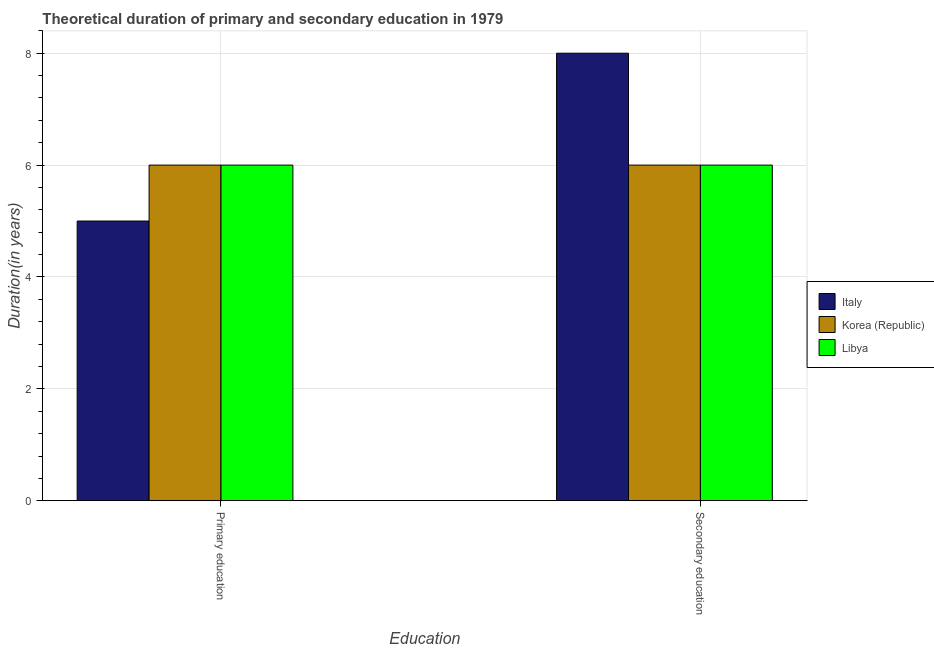How many different coloured bars are there?
Offer a very short reply. 3. How many groups of bars are there?
Provide a succinct answer. 2. Are the number of bars per tick equal to the number of legend labels?
Provide a succinct answer. Yes. How many bars are there on the 1st tick from the right?
Provide a succinct answer. 3. What is the label of the 2nd group of bars from the left?
Provide a succinct answer. Secondary education. What is the duration of secondary education in Korea (Republic)?
Give a very brief answer. 6. Across all countries, what is the minimum duration of primary education?
Offer a very short reply. 5. In which country was the duration of primary education maximum?
Provide a short and direct response. Korea (Republic). In which country was the duration of secondary education minimum?
Offer a very short reply. Korea (Republic). What is the total duration of primary education in the graph?
Provide a short and direct response. 17. What is the difference between the duration of secondary education in Libya and that in Italy?
Offer a terse response. -2. What is the difference between the duration of secondary education in Libya and the duration of primary education in Korea (Republic)?
Keep it short and to the point. 0. What is the average duration of secondary education per country?
Provide a short and direct response. 6.67. What is the ratio of the duration of primary education in Korea (Republic) to that in Libya?
Offer a terse response. 1. Is the duration of primary education in Italy less than that in Korea (Republic)?
Offer a very short reply. Yes. What does the 2nd bar from the left in Secondary education represents?
Give a very brief answer. Korea (Republic). What does the 1st bar from the right in Primary education represents?
Ensure brevity in your answer.  Libya. How many bars are there?
Make the answer very short. 6. Are all the bars in the graph horizontal?
Your answer should be compact. No. How many countries are there in the graph?
Provide a short and direct response. 3. What is the difference between two consecutive major ticks on the Y-axis?
Offer a very short reply. 2. Are the values on the major ticks of Y-axis written in scientific E-notation?
Keep it short and to the point. No. Does the graph contain any zero values?
Ensure brevity in your answer.  No. Does the graph contain grids?
Your answer should be very brief. Yes. How many legend labels are there?
Your answer should be very brief. 3. What is the title of the graph?
Your response must be concise. Theoretical duration of primary and secondary education in 1979. What is the label or title of the X-axis?
Provide a short and direct response. Education. What is the label or title of the Y-axis?
Your response must be concise. Duration(in years). What is the Duration(in years) of Korea (Republic) in Primary education?
Offer a very short reply. 6. What is the Duration(in years) in Libya in Primary education?
Keep it short and to the point. 6. What is the Duration(in years) of Italy in Secondary education?
Ensure brevity in your answer.  8. What is the Duration(in years) in Korea (Republic) in Secondary education?
Your answer should be compact. 6. Across all Education, what is the maximum Duration(in years) of Italy?
Keep it short and to the point. 8. Across all Education, what is the maximum Duration(in years) in Korea (Republic)?
Your response must be concise. 6. Across all Education, what is the maximum Duration(in years) of Libya?
Keep it short and to the point. 6. Across all Education, what is the minimum Duration(in years) in Italy?
Your response must be concise. 5. What is the total Duration(in years) in Italy in the graph?
Provide a succinct answer. 13. What is the total Duration(in years) of Libya in the graph?
Your response must be concise. 12. What is the difference between the Duration(in years) of Korea (Republic) in Primary education and that in Secondary education?
Keep it short and to the point. 0. What is the difference between the Duration(in years) in Italy in Primary education and the Duration(in years) in Korea (Republic) in Secondary education?
Make the answer very short. -1. What is the difference between the Duration(in years) in Korea (Republic) in Primary education and the Duration(in years) in Libya in Secondary education?
Offer a terse response. 0. What is the average Duration(in years) in Italy per Education?
Your answer should be compact. 6.5. What is the average Duration(in years) in Korea (Republic) per Education?
Provide a short and direct response. 6. What is the average Duration(in years) of Libya per Education?
Ensure brevity in your answer.  6. What is the difference between the Duration(in years) in Italy and Duration(in years) in Korea (Republic) in Primary education?
Ensure brevity in your answer.  -1. What is the difference between the highest and the second highest Duration(in years) in Italy?
Provide a short and direct response. 3. What is the difference between the highest and the second highest Duration(in years) of Korea (Republic)?
Your response must be concise. 0. What is the difference between the highest and the lowest Duration(in years) of Libya?
Keep it short and to the point. 0. 